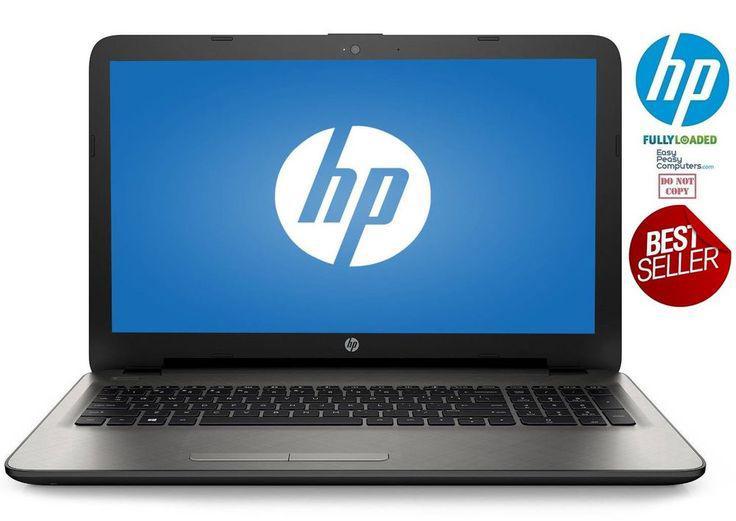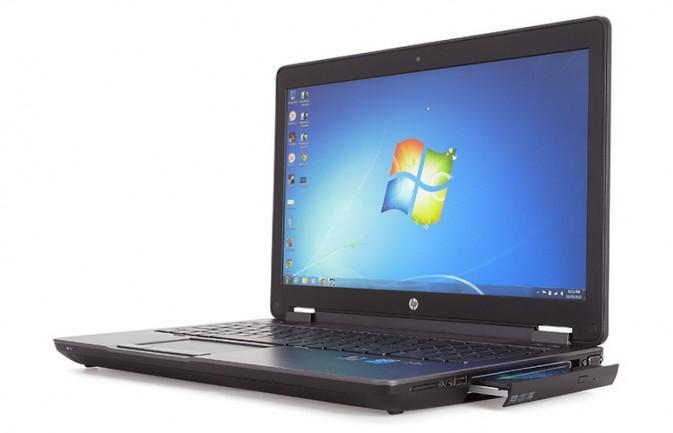The first image is the image on the left, the second image is the image on the right. Given the left and right images, does the statement "The laptop in the right image is displayed turned at an angle." hold true? Answer yes or no. Yes. 